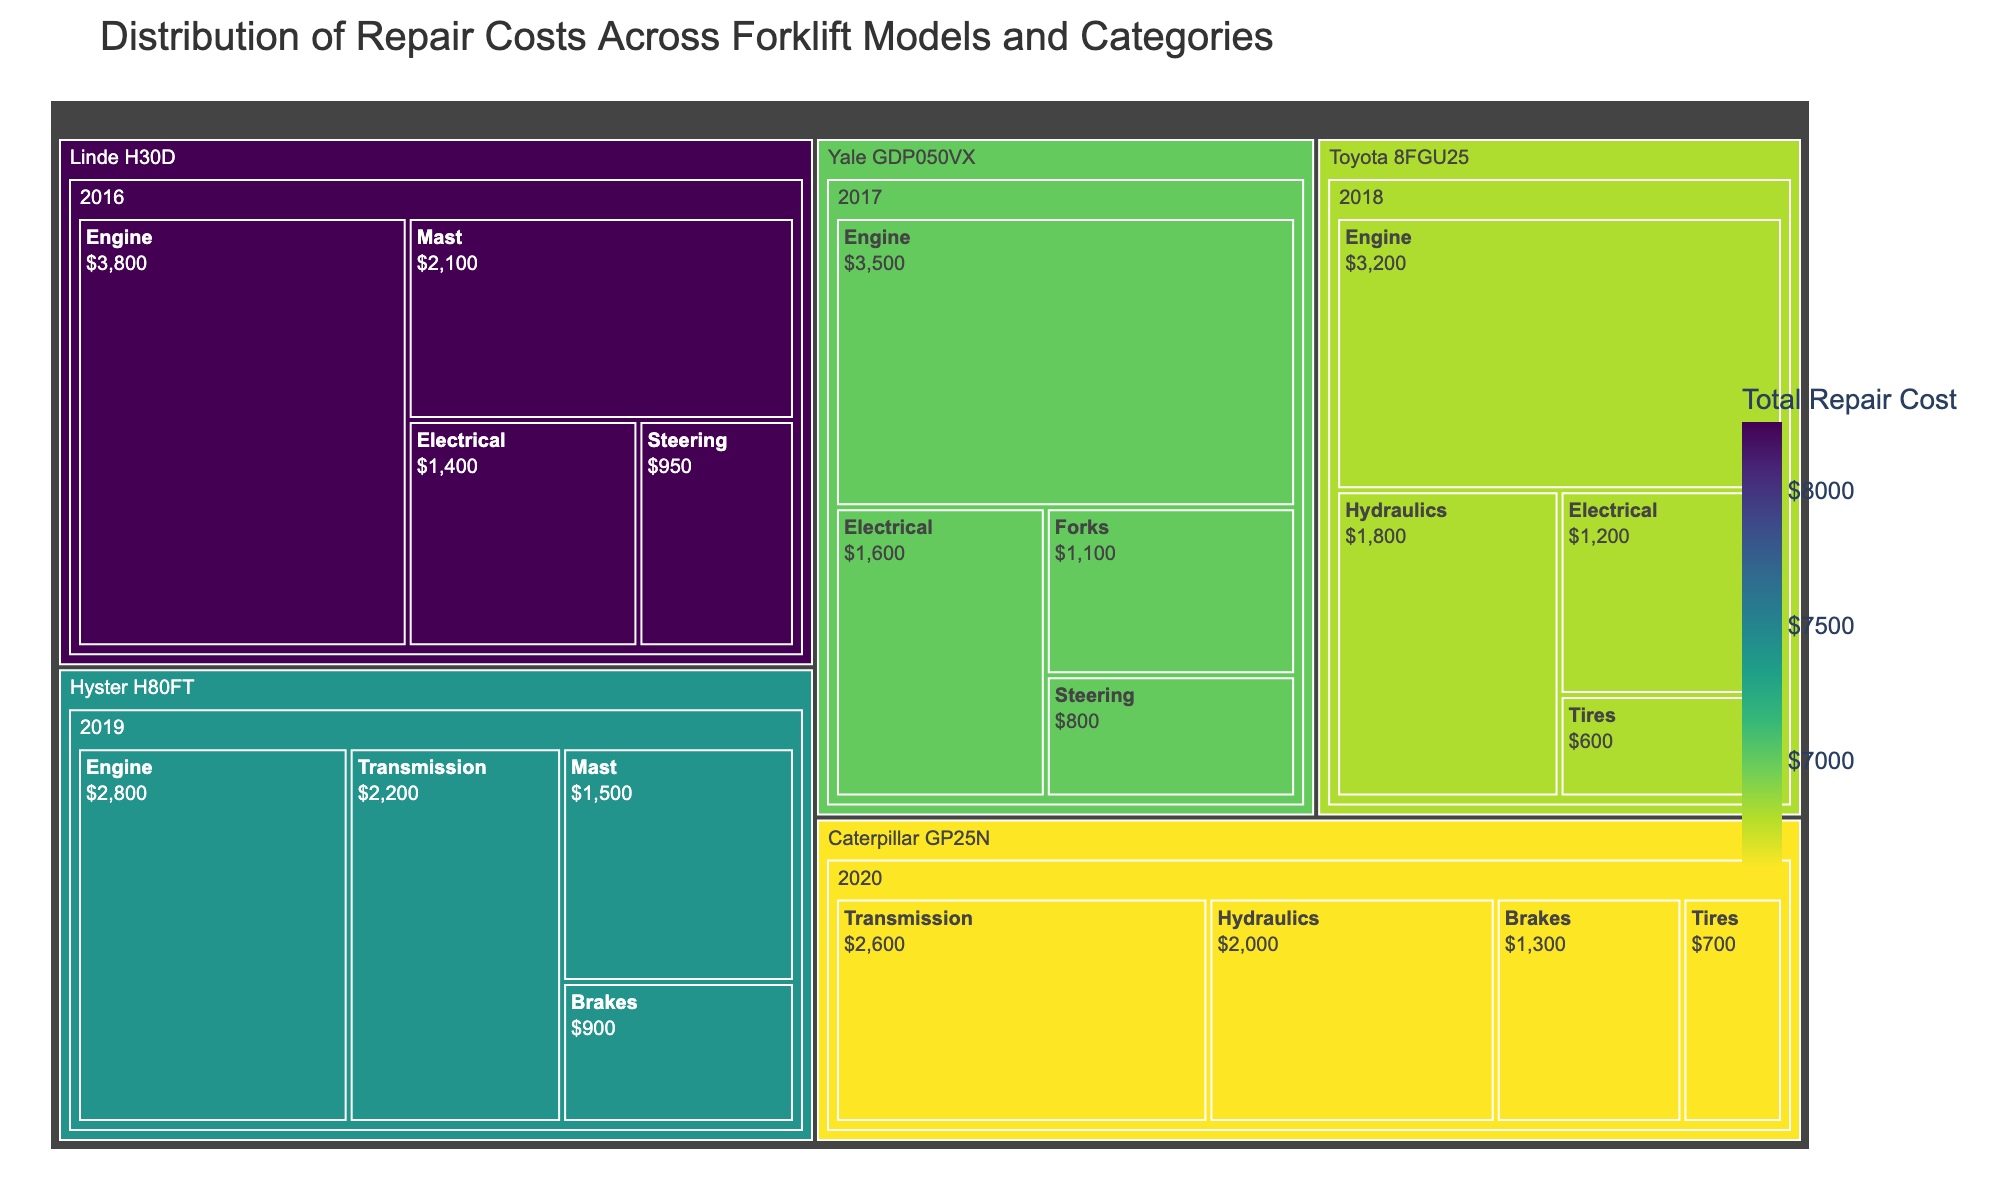What is the title of the figure? The title of the figure is displayed at the top of the treemap and is used to describe the content of the plot.
Answer: Distribution of Repair Costs Across Forklift Models and Categories Which forklift model has the highest total repair cost? To find the model with the highest total repair cost, look for the largest or most prominently colored section in the treemap.
Answer: Linde H30D How much is the repair cost for the 'Engine' category of the 'Toyota 8FGU25' model? Locate the 'Toyota 8FGU25' model, then navigate to the 'Engine' category within that model and check the repair cost displayed.
Answer: $3200 What are the categories with the repair costs for the 'Hyster H80FT' model? Locate the 'Hyster H80FT' model in the treemap, then list all visible categories and their respective repair costs within that model.
Answer: Engine: $2800, Transmission: $2200, Mast: $1500, Brakes: $900 Which year has the highest repair cost for the 'Caterpillar GP25N' model? Find the 'Caterpillar GP25N' model and inspect the repair costs by year; the year with the highest total is the answer.
Answer: 2020 Compare the repair costs of the 'Engine' category between 'Yale GDP050VX' and 'Linde H30D' models. Which one is higher and by how much? Find the 'Engine' category repair costs for both 'Yale GDP050VX' and 'Linde H30D' models, then subtract the lesser value from the greater one to find the difference.
Answer: Linde H30D is higher by $300 What is the total repair cost for the 'Transmission' category across all forklift models? Identify the 'Transmission' category repair costs in all forklift models and sum them up.
Answer: $4800 Which forklift model from 2017 has the highest total repair cost? Locate all models from the year 2017 and compare their total repair costs to find the highest one.
Answer: Yale GDP050VX What is the average repair cost for the 'Electrical' category across all years and models? Find all 'Electrical' category repair costs, sum them up, and divide by the total number of 'Electrical' repair instances.
Answer: $1400 How do the repair costs for 'Hydraulics' in 'Toyota 8FGU25' compare with 'Caterpillar GP25N'? Locate the 'Hydraulics' repair costs for both 'Toyota 8FGU25' and 'Caterpillar GP25N', then compare the two values to determine any differences.
Answer: Caterpillar GP25N is higher by $200 